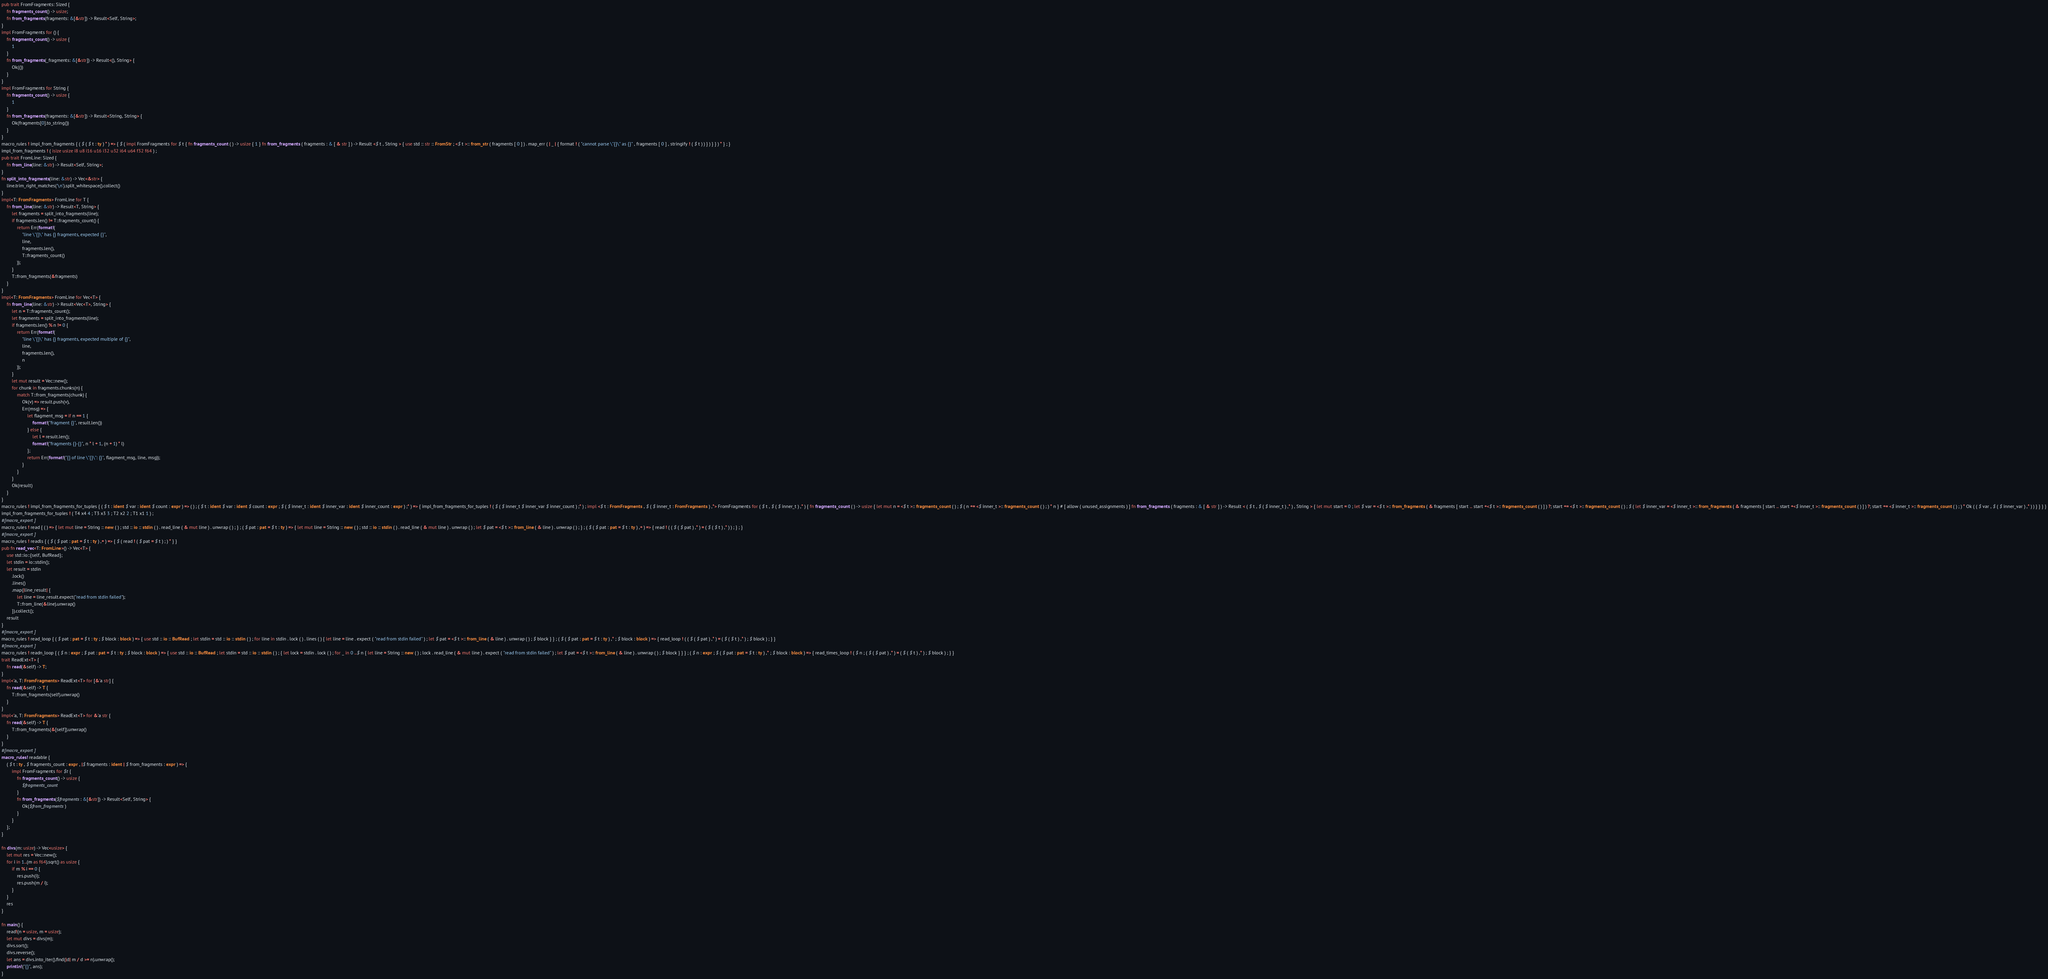<code> <loc_0><loc_0><loc_500><loc_500><_Rust_>pub trait FromFragments: Sized {
    fn fragments_count() -> usize;
    fn from_fragments(fragments: &[&str]) -> Result<Self, String>;
}
impl FromFragments for () {
    fn fragments_count() -> usize {
        1
    }
    fn from_fragments(_fragments: &[&str]) -> Result<(), String> {
        Ok(())
    }
}
impl FromFragments for String {
    fn fragments_count() -> usize {
        1
    }
    fn from_fragments(fragments: &[&str]) -> Result<String, String> {
        Ok(fragments[0].to_string())
    }
}
macro_rules ! impl_from_fragments { ( $ ( $ t : ty ) * ) => { $ ( impl FromFragments for $ t { fn fragments_count ( ) -> usize { 1 } fn from_fragments ( fragments : & [ & str ] ) -> Result <$ t , String > { use std :: str :: FromStr ; <$ t >:: from_str ( fragments [ 0 ] ) . map_err ( | _ | { format ! ( "cannot parse \"{}\" as {}" , fragments [ 0 ] , stringify ! ( $ t ) ) } ) } } ) * } ; }
impl_from_fragments ! ( isize usize i8 u8 i16 u16 i32 u32 i64 u64 f32 f64 ) ;
pub trait FromLine: Sized {
    fn from_line(line: &str) -> Result<Self, String>;
}
fn split_into_fragments(line: &str) -> Vec<&str> {
    line.trim_right_matches('\n').split_whitespace().collect()
}
impl<T: FromFragments> FromLine for T {
    fn from_line(line: &str) -> Result<T, String> {
        let fragments = split_into_fragments(line);
        if fragments.len() != T::fragments_count() {
            return Err(format!(
                "line \"{}\" has {} fragments, expected {}",
                line,
                fragments.len(),
                T::fragments_count()
            ));
        }
        T::from_fragments(&fragments)
    }
}
impl<T: FromFragments> FromLine for Vec<T> {
    fn from_line(line: &str) -> Result<Vec<T>, String> {
        let n = T::fragments_count();
        let fragments = split_into_fragments(line);
        if fragments.len() % n != 0 {
            return Err(format!(
                "line \"{}\" has {} fragments, expected multiple of {}",
                line,
                fragments.len(),
                n
            ));
        }
        let mut result = Vec::new();
        for chunk in fragments.chunks(n) {
            match T::from_fragments(chunk) {
                Ok(v) => result.push(v),
                Err(msg) => {
                    let flagment_msg = if n == 1 {
                        format!("fragment {}", result.len())
                    } else {
                        let l = result.len();
                        format!("fragments {}-{}", n * l + 1, (n + 1) * l)
                    };
                    return Err(format!("{} of line \"{}\": {}", flagment_msg, line, msg));
                }
            }
        }
        Ok(result)
    }
}
macro_rules ! impl_from_fragments_for_tuples { ( $ t : ident $ var : ident $ count : expr ) => ( ) ; ( $ t : ident $ var : ident $ count : expr ; $ ( $ inner_t : ident $ inner_var : ident $ inner_count : expr ) ;* ) => { impl_from_fragments_for_tuples ! ( $ ( $ inner_t $ inner_var $ inner_count ) ;* ) ; impl <$ t : FromFragments , $ ( $ inner_t : FromFragments ) ,*> FromFragments for ( $ t , $ ( $ inner_t ) ,* ) { fn fragments_count ( ) -> usize { let mut n = <$ t >:: fragments_count ( ) ; $ ( n += <$ inner_t >:: fragments_count ( ) ; ) * n } # [ allow ( unused_assignments ) ] fn from_fragments ( fragments : & [ & str ] ) -> Result < ( $ t , $ ( $ inner_t ) ,* ) , String > { let mut start = 0 ; let $ var = <$ t >:: from_fragments ( & fragments [ start .. start +<$ t >:: fragments_count ( ) ] ) ?; start += <$ t >:: fragments_count ( ) ; $ ( let $ inner_var = <$ inner_t >:: from_fragments ( & fragments [ start .. start +<$ inner_t >:: fragments_count ( ) ] ) ?; start += <$ inner_t >:: fragments_count ( ) ; ) * Ok ( ( $ var , $ ( $ inner_var ) ,* ) ) } } } }
impl_from_fragments_for_tuples ! ( T4 x4 4 ; T3 x3 3 ; T2 x2 2 ; T1 x1 1 ) ;
#[macro_export]
macro_rules ! read { ( ) => { let mut line = String :: new ( ) ; std :: io :: stdin ( ) . read_line ( & mut line ) . unwrap ( ) ; } ; ( $ pat : pat = $ t : ty ) => { let mut line = String :: new ( ) ; std :: io :: stdin ( ) . read_line ( & mut line ) . unwrap ( ) ; let $ pat = <$ t >:: from_line ( & line ) . unwrap ( ) ; } ; ( $ ( $ pat : pat = $ t : ty ) ,+ ) => { read ! ( ( $ ( $ pat ) ,* ) = ( $ ( $ t ) ,* ) ) ; } ; }
#[macro_export]
macro_rules ! readls { ( $ ( $ pat : pat = $ t : ty ) ,+ ) => { $ ( read ! ( $ pat = $ t ) ; ) * } }
pub fn read_vec<T: FromLine>() -> Vec<T> {
    use std::io::{self, BufRead};
    let stdin = io::stdin();
    let result = stdin
        .lock()
        .lines()
        .map(|line_result| {
            let line = line_result.expect("read from stdin failed");
            T::from_line(&line).unwrap()
        }).collect();
    result
}
#[macro_export]
macro_rules ! read_loop { ( $ pat : pat = $ t : ty ; $ block : block ) => { use std :: io :: BufRead ; let stdin = std :: io :: stdin ( ) ; for line in stdin . lock ( ) . lines ( ) { let line = line . expect ( "read from stdin failed" ) ; let $ pat = <$ t >:: from_line ( & line ) . unwrap ( ) ; $ block } } ; ( $ ( $ pat : pat = $ t : ty ) ,* ; $ block : block ) => { read_loop ! ( ( $ ( $ pat ) ,* ) = ( $ ( $ t ) ,* ) ; $ block ) ; } }
#[macro_export]
macro_rules ! readn_loop { ( $ n : expr ; $ pat : pat = $ t : ty ; $ block : block ) => { use std :: io :: BufRead ; let stdin = std :: io :: stdin ( ) ; { let lock = stdin . lock ( ) ; for _ in 0 ..$ n { let line = String :: new ( ) ; lock . read_line ( & mut line ) . expect ( "read from stdin failed" ) ; let $ pat = <$ t >:: from_line ( & line ) . unwrap ( ) ; $ block } } } ; ( $ n : expr ; $ ( $ pat : pat = $ t : ty ) ,* ; $ block : block ) => { read_times_loop ! ( $ n ; ( $ ( $ pat ) ,* ) = ( $ ( $ t ) ,* ) ; $ block ) ; } }
trait ReadExt<T> {
    fn read(&self) -> T;
}
impl<'a, T: FromFragments> ReadExt<T> for [&'a str] {
    fn read(&self) -> T {
        T::from_fragments(self).unwrap()
    }
}
impl<'a, T: FromFragments> ReadExt<T> for &'a str {
    fn read(&self) -> T {
        T::from_fragments(&[self]).unwrap()
    }
}
#[macro_export]
macro_rules! readable {
    ( $ t : ty , $ fragments_count : expr , |$ fragments : ident | $ from_fragments : expr ) => {
        impl FromFragments for $t {
            fn fragments_count() -> usize {
                $fragments_count
            }
            fn from_fragments($fragments: &[&str]) -> Result<Self, String> {
                Ok($from_fragments)
            }
        }
    };
}

fn divs(m: usize) -> Vec<usize> {
    let mut res = Vec::new();
    for i in 1..(m as f64).sqrt() as usize {
        if m % i == 0 {
            res.push(i);
            res.push(m / i);
        }
    }
    res
}

fn main() {
    read!(n = usize, m = usize);
    let mut divs = divs(m);
    divs.sort();
    divs.reverse();
    let ans = divs.into_iter().find(|d| m / d >= n).unwrap();
    println!("{}", ans);
}
</code> 